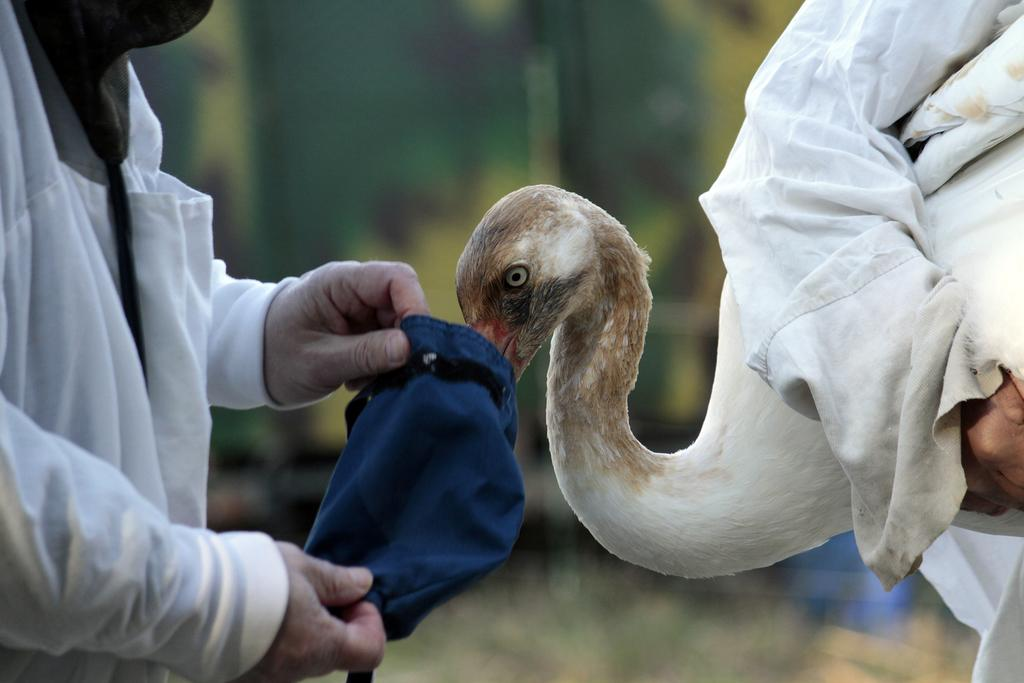What is the man in the image doing? The man is standing in the image and holding a bag. Can you describe the person on the right side of the image? The person on the right side of the image is holding a bird. How would you describe the background of the image? The background of the image is blurry. What type of oil is being used to lubricate the agreement between the man and the bird in the image? There is no mention of an agreement or oil in the image; it simply shows a man holding a bag and a person holding a bird with a blurry background. 